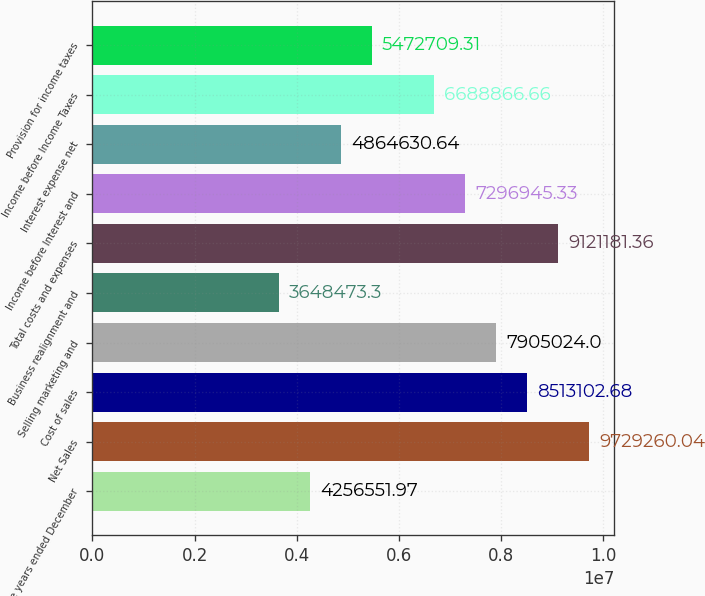Convert chart. <chart><loc_0><loc_0><loc_500><loc_500><bar_chart><fcel>For the years ended December<fcel>Net Sales<fcel>Cost of sales<fcel>Selling marketing and<fcel>Business realignment and<fcel>Total costs and expenses<fcel>Income before Interest and<fcel>Interest expense net<fcel>Income before Income Taxes<fcel>Provision for income taxes<nl><fcel>4.25655e+06<fcel>9.72926e+06<fcel>8.5131e+06<fcel>7.90502e+06<fcel>3.64847e+06<fcel>9.12118e+06<fcel>7.29695e+06<fcel>4.86463e+06<fcel>6.68887e+06<fcel>5.47271e+06<nl></chart> 